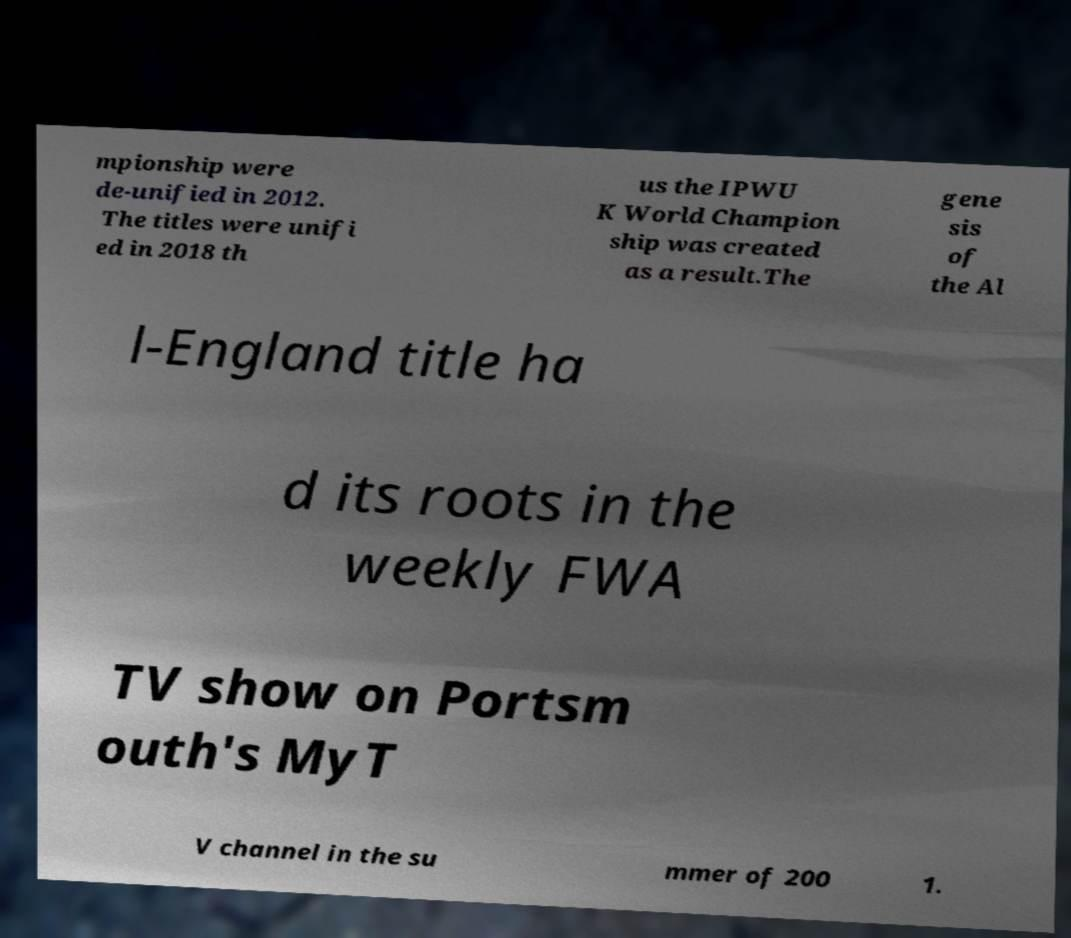Please read and relay the text visible in this image. What does it say? mpionship were de-unified in 2012. The titles were unifi ed in 2018 th us the IPWU K World Champion ship was created as a result.The gene sis of the Al l-England title ha d its roots in the weekly FWA TV show on Portsm outh's MyT V channel in the su mmer of 200 1. 